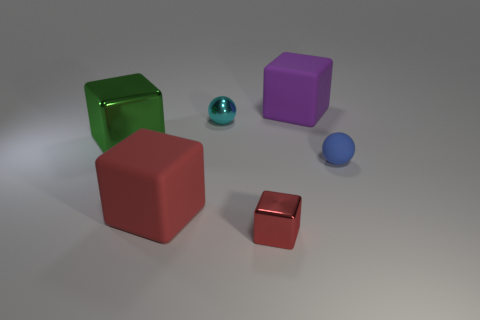Subtract all big cubes. How many cubes are left? 1 Subtract 1 cubes. How many cubes are left? 3 Subtract all yellow cubes. Subtract all green spheres. How many cubes are left? 4 Add 3 cyan metallic things. How many objects exist? 9 Subtract all spheres. How many objects are left? 4 Subtract all big cubes. Subtract all large green matte blocks. How many objects are left? 3 Add 6 tiny matte things. How many tiny matte things are left? 7 Add 4 big metallic things. How many big metallic things exist? 5 Subtract 0 yellow cylinders. How many objects are left? 6 